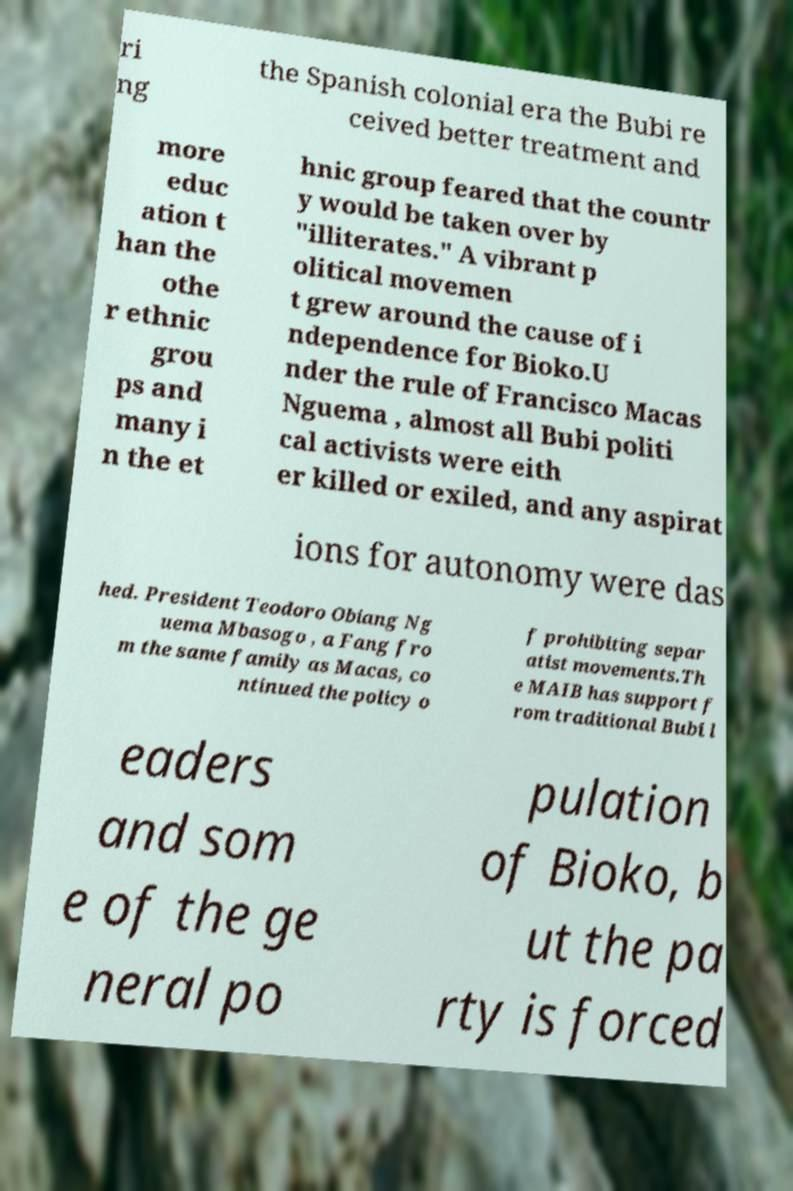I need the written content from this picture converted into text. Can you do that? ri ng the Spanish colonial era the Bubi re ceived better treatment and more educ ation t han the othe r ethnic grou ps and many i n the et hnic group feared that the countr y would be taken over by "illiterates." A vibrant p olitical movemen t grew around the cause of i ndependence for Bioko.U nder the rule of Francisco Macas Nguema , almost all Bubi politi cal activists were eith er killed or exiled, and any aspirat ions for autonomy were das hed. President Teodoro Obiang Ng uema Mbasogo , a Fang fro m the same family as Macas, co ntinued the policy o f prohibiting separ atist movements.Th e MAIB has support f rom traditional Bubi l eaders and som e of the ge neral po pulation of Bioko, b ut the pa rty is forced 